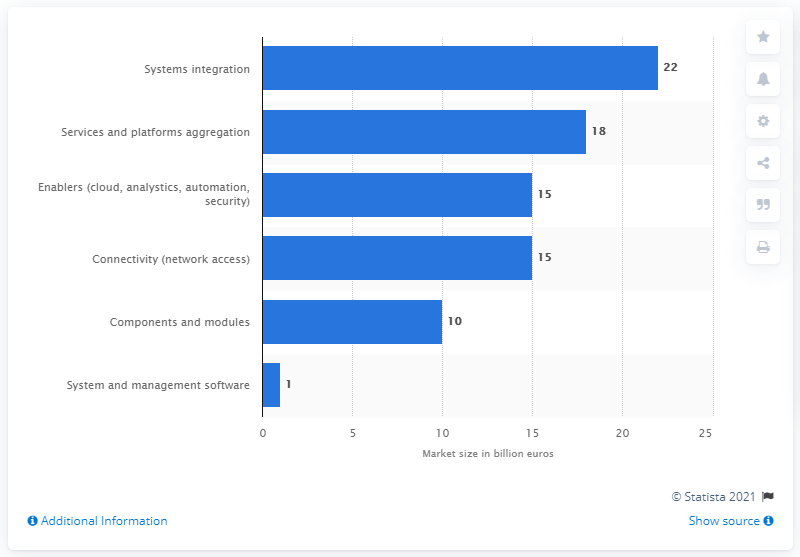Indicate a few pertinent items in this graphic. According to estimates, the value of enablers of IoT is expected to reach $15 trillion by 2025. 